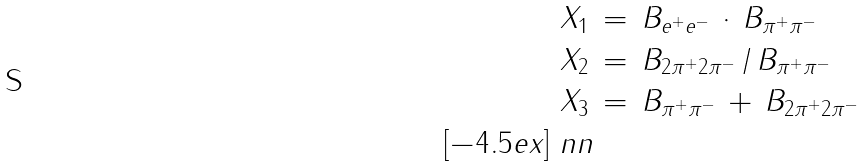<formula> <loc_0><loc_0><loc_500><loc_500>X _ { 1 } \, & = \, B _ { e ^ { + } e ^ { - } } \, \cdot \, B _ { \pi ^ { + } \pi ^ { - } } \\ X _ { 2 } \, & = \, B _ { 2 \pi ^ { + } 2 \pi ^ { - } } \, / \, B _ { \pi ^ { + } \pi ^ { - } } \\ X _ { 3 } \, & = \, B _ { \pi ^ { + } \pi ^ { - } } \, + \, B _ { 2 \pi ^ { + } 2 \pi ^ { - } } \\ [ - 4 . 5 e x ] \ n n</formula> 